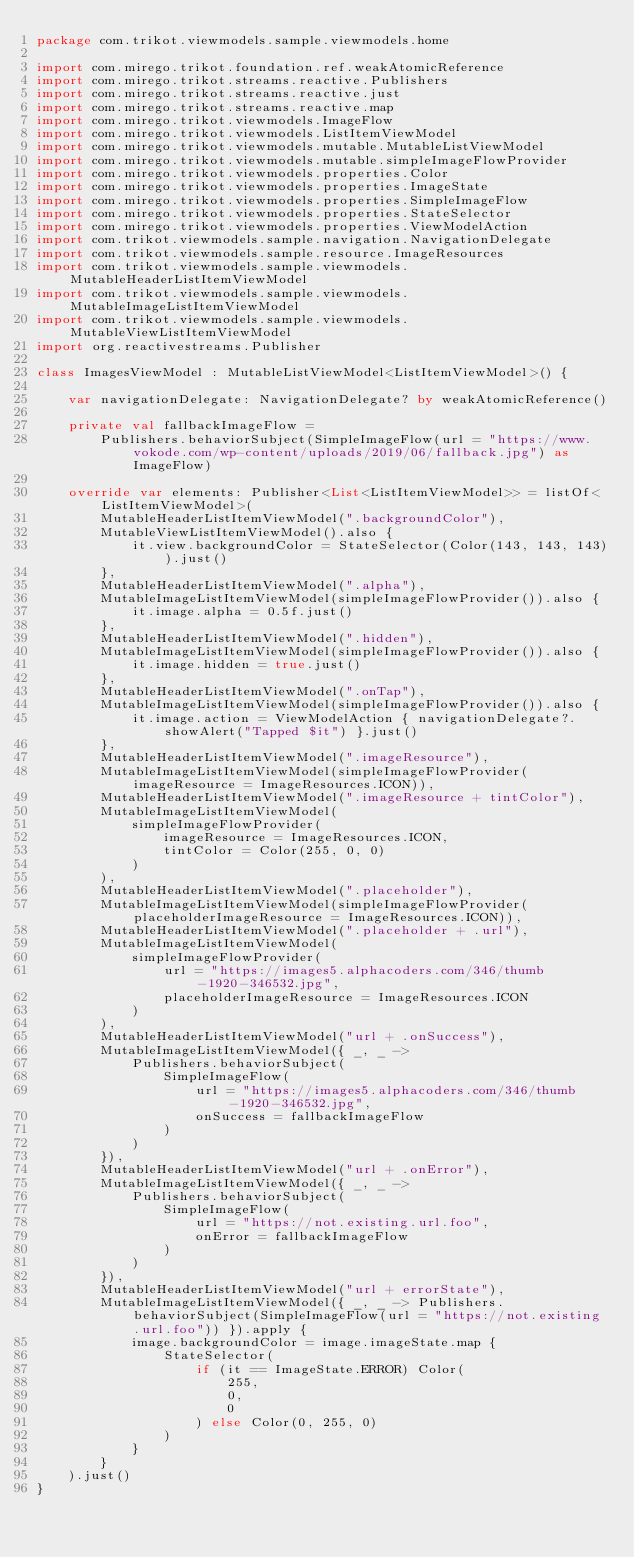Convert code to text. <code><loc_0><loc_0><loc_500><loc_500><_Kotlin_>package com.trikot.viewmodels.sample.viewmodels.home

import com.mirego.trikot.foundation.ref.weakAtomicReference
import com.mirego.trikot.streams.reactive.Publishers
import com.mirego.trikot.streams.reactive.just
import com.mirego.trikot.streams.reactive.map
import com.mirego.trikot.viewmodels.ImageFlow
import com.mirego.trikot.viewmodels.ListItemViewModel
import com.mirego.trikot.viewmodels.mutable.MutableListViewModel
import com.mirego.trikot.viewmodels.mutable.simpleImageFlowProvider
import com.mirego.trikot.viewmodels.properties.Color
import com.mirego.trikot.viewmodels.properties.ImageState
import com.mirego.trikot.viewmodels.properties.SimpleImageFlow
import com.mirego.trikot.viewmodels.properties.StateSelector
import com.mirego.trikot.viewmodels.properties.ViewModelAction
import com.trikot.viewmodels.sample.navigation.NavigationDelegate
import com.trikot.viewmodels.sample.resource.ImageResources
import com.trikot.viewmodels.sample.viewmodels.MutableHeaderListItemViewModel
import com.trikot.viewmodels.sample.viewmodels.MutableImageListItemViewModel
import com.trikot.viewmodels.sample.viewmodels.MutableViewListItemViewModel
import org.reactivestreams.Publisher

class ImagesViewModel : MutableListViewModel<ListItemViewModel>() {

    var navigationDelegate: NavigationDelegate? by weakAtomicReference()

    private val fallbackImageFlow =
        Publishers.behaviorSubject(SimpleImageFlow(url = "https://www.vokode.com/wp-content/uploads/2019/06/fallback.jpg") as ImageFlow)

    override var elements: Publisher<List<ListItemViewModel>> = listOf<ListItemViewModel>(
        MutableHeaderListItemViewModel(".backgroundColor"),
        MutableViewListItemViewModel().also {
            it.view.backgroundColor = StateSelector(Color(143, 143, 143)).just()
        },
        MutableHeaderListItemViewModel(".alpha"),
        MutableImageListItemViewModel(simpleImageFlowProvider()).also {
            it.image.alpha = 0.5f.just()
        },
        MutableHeaderListItemViewModel(".hidden"),
        MutableImageListItemViewModel(simpleImageFlowProvider()).also {
            it.image.hidden = true.just()
        },
        MutableHeaderListItemViewModel(".onTap"),
        MutableImageListItemViewModel(simpleImageFlowProvider()).also {
            it.image.action = ViewModelAction { navigationDelegate?.showAlert("Tapped $it") }.just()
        },
        MutableHeaderListItemViewModel(".imageResource"),
        MutableImageListItemViewModel(simpleImageFlowProvider(imageResource = ImageResources.ICON)),
        MutableHeaderListItemViewModel(".imageResource + tintColor"),
        MutableImageListItemViewModel(
            simpleImageFlowProvider(
                imageResource = ImageResources.ICON,
                tintColor = Color(255, 0, 0)
            )
        ),
        MutableHeaderListItemViewModel(".placeholder"),
        MutableImageListItemViewModel(simpleImageFlowProvider(placeholderImageResource = ImageResources.ICON)),
        MutableHeaderListItemViewModel(".placeholder + .url"),
        MutableImageListItemViewModel(
            simpleImageFlowProvider(
                url = "https://images5.alphacoders.com/346/thumb-1920-346532.jpg",
                placeholderImageResource = ImageResources.ICON
            )
        ),
        MutableHeaderListItemViewModel("url + .onSuccess"),
        MutableImageListItemViewModel({ _, _ ->
            Publishers.behaviorSubject(
                SimpleImageFlow(
                    url = "https://images5.alphacoders.com/346/thumb-1920-346532.jpg",
                    onSuccess = fallbackImageFlow
                )
            )
        }),
        MutableHeaderListItemViewModel("url + .onError"),
        MutableImageListItemViewModel({ _, _ ->
            Publishers.behaviorSubject(
                SimpleImageFlow(
                    url = "https://not.existing.url.foo",
                    onError = fallbackImageFlow
                )
            )
        }),
        MutableHeaderListItemViewModel("url + errorState"),
        MutableImageListItemViewModel({ _, _ -> Publishers.behaviorSubject(SimpleImageFlow(url = "https://not.existing.url.foo")) }).apply {
            image.backgroundColor = image.imageState.map {
                StateSelector(
                    if (it == ImageState.ERROR) Color(
                        255,
                        0,
                        0
                    ) else Color(0, 255, 0)
                )
            }
        }
    ).just()
}
</code> 